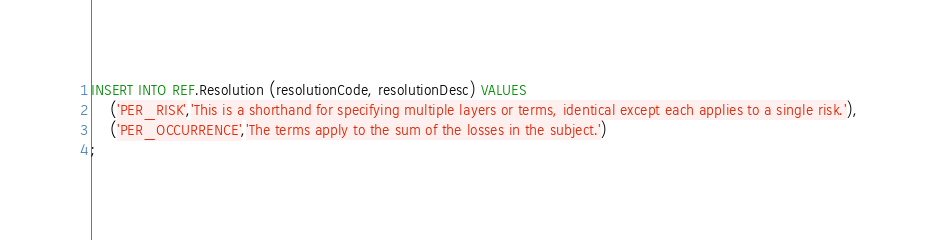Convert code to text. <code><loc_0><loc_0><loc_500><loc_500><_SQL_>INSERT INTO REF.Resolution (resolutionCode, resolutionDesc) VALUES
    ('PER_RISK','This is a shorthand for specifying multiple layers or terms, identical except each applies to a single risk.'),
    ('PER_OCCURRENCE','The terms apply to the sum of the losses in the subject.')
;    
</code> 